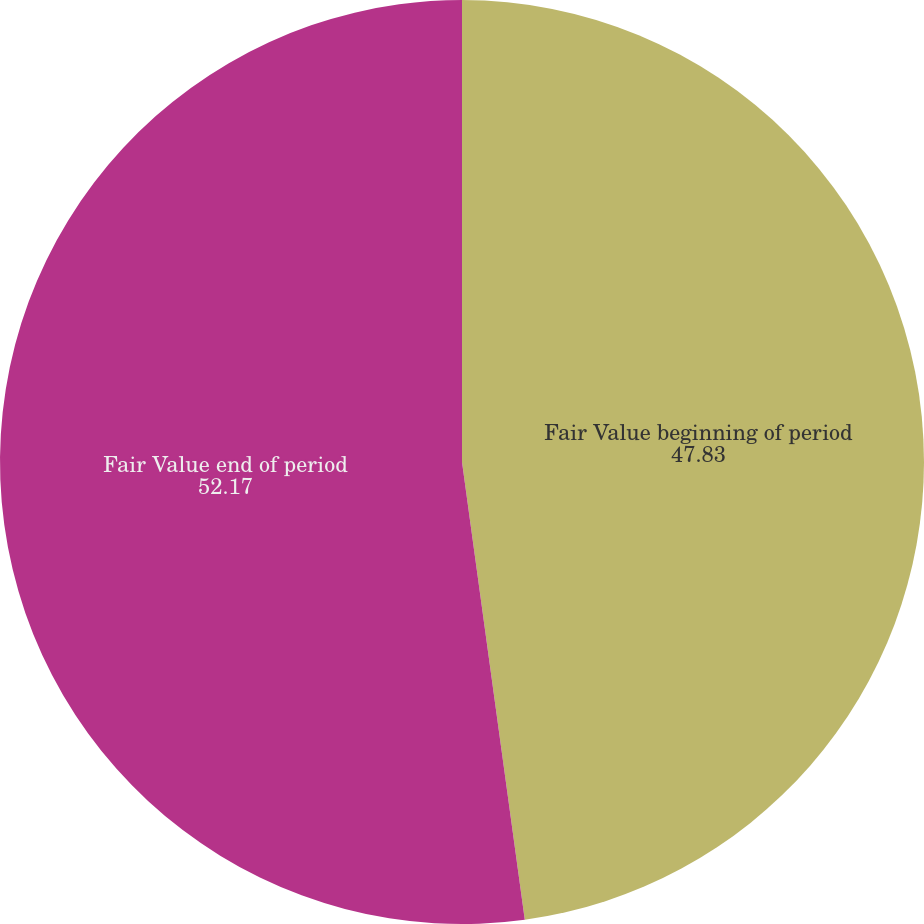Convert chart. <chart><loc_0><loc_0><loc_500><loc_500><pie_chart><fcel>Fair Value beginning of period<fcel>Fair Value end of period<nl><fcel>47.83%<fcel>52.17%<nl></chart> 